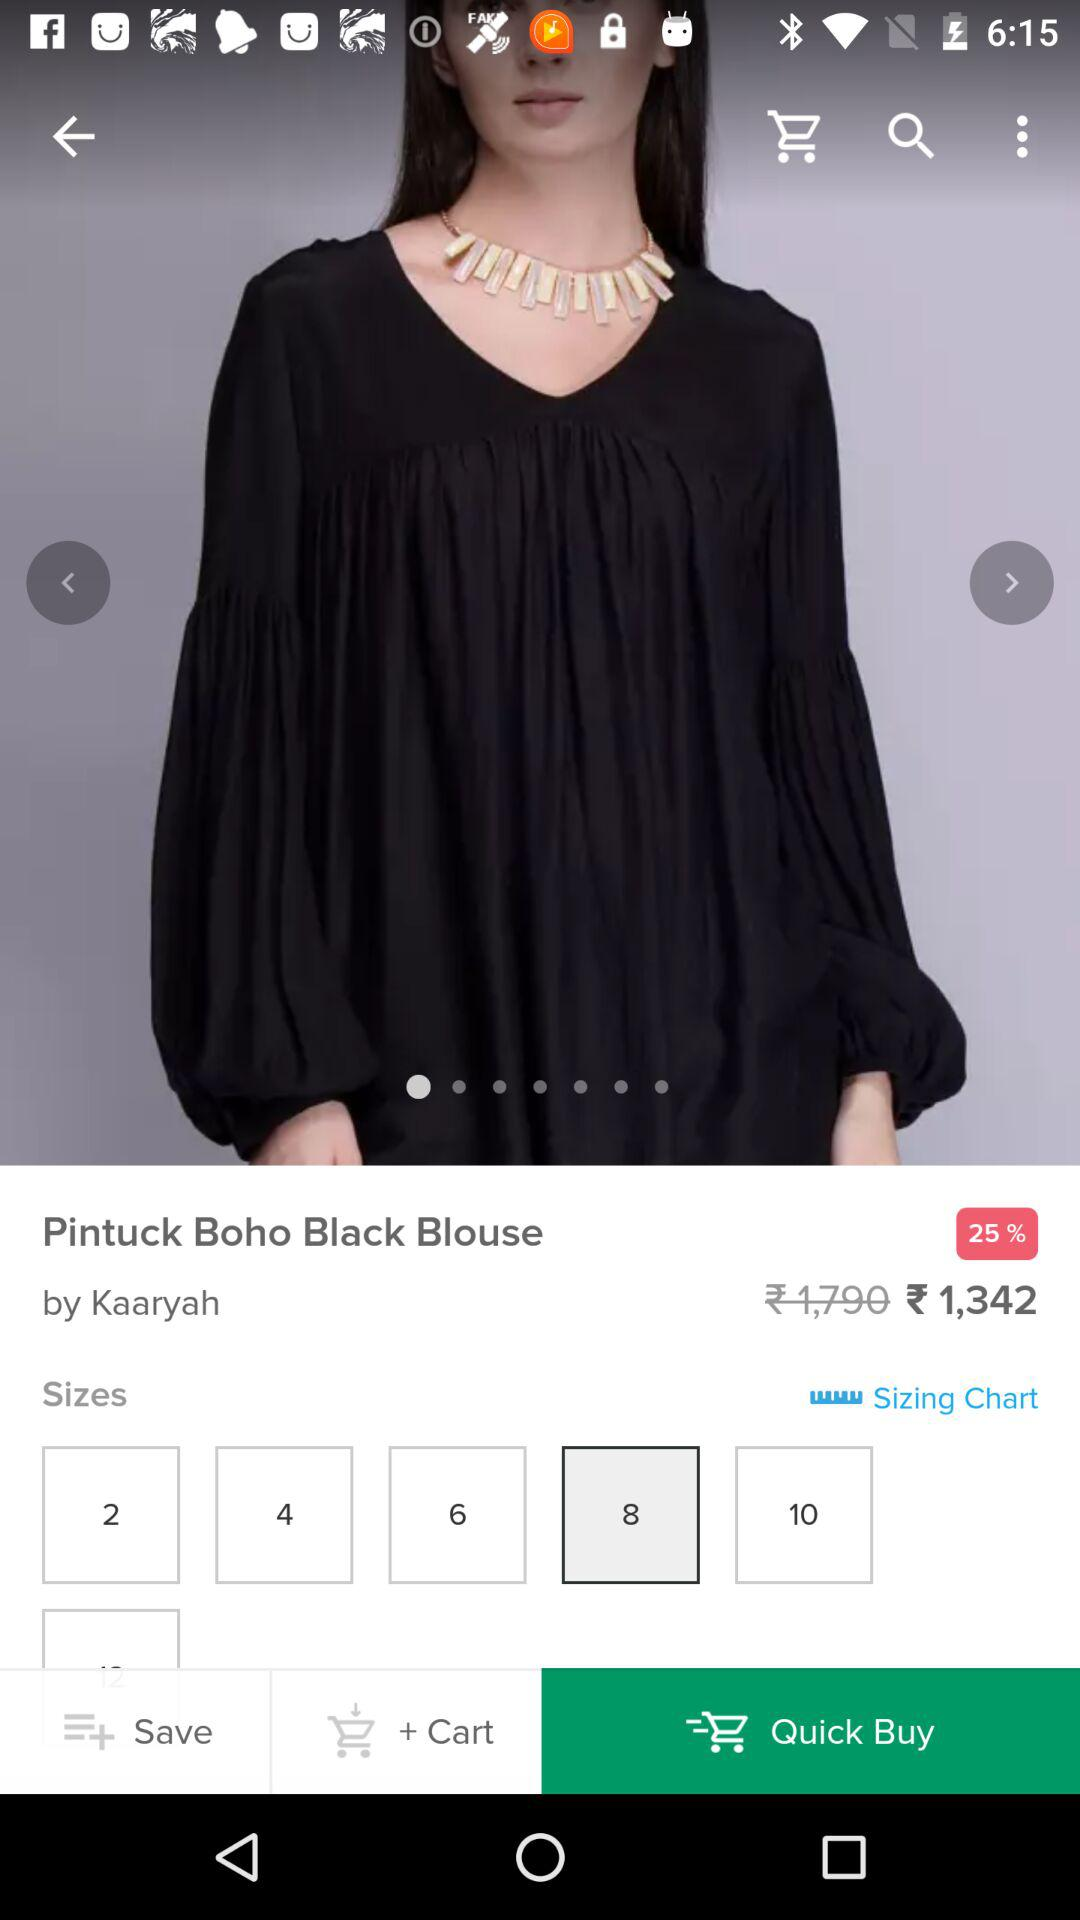What is the selected size? The selected size is 8. 